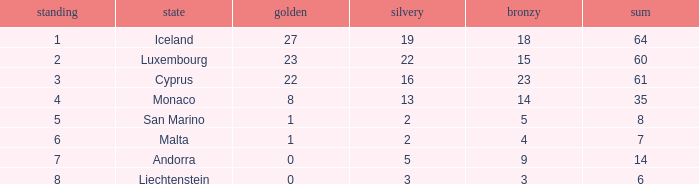How many bronzes for nations with over 22 golds and ranked under 2? 18.0. 